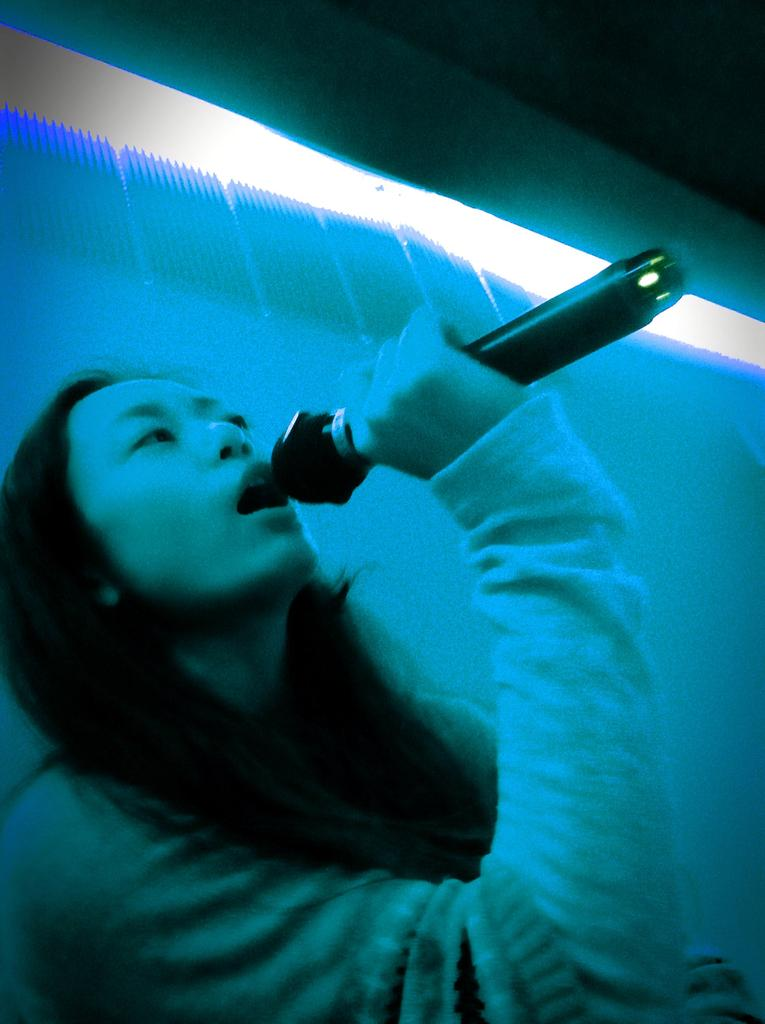Who is the main subject in the foreground of the picture? There is a woman in the foreground of the picture. What is the woman holding in the image? The woman is holding a microphone. What is the woman doing in the image? The woman is singing. What can be seen at the top of the image? There is light visible at the top of the image. Where are the cows located in the image? There are no cows present in the image. What type of club can be seen in the woman's hand in the image? The woman is holding a microphone, not a club, in the image. 